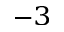<formula> <loc_0><loc_0><loc_500><loc_500>^ { - 3 }</formula> 